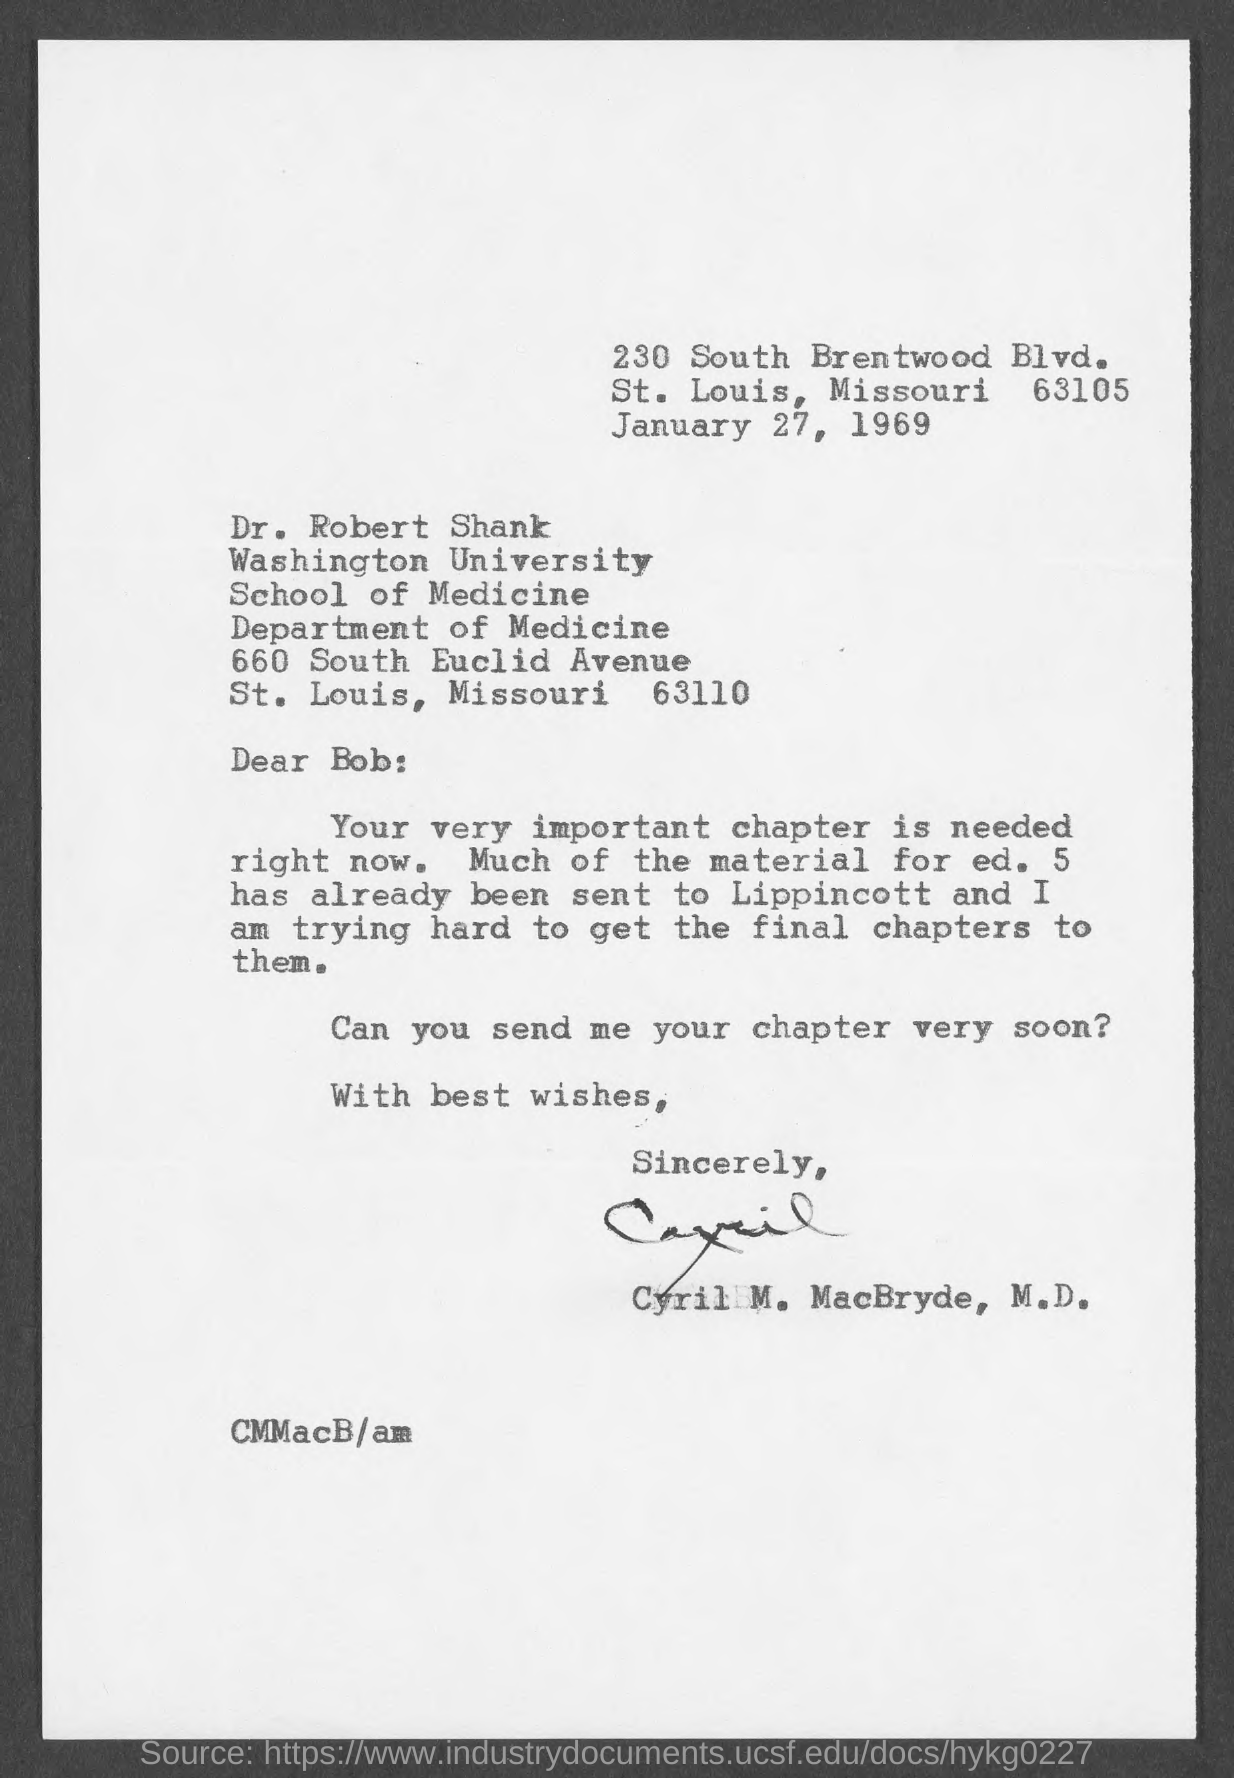Specify some key components in this picture. The date mentioned in the given letter is January 27, 1969. The signature at the end of the letter was that of Cyril M. MacBryde. 